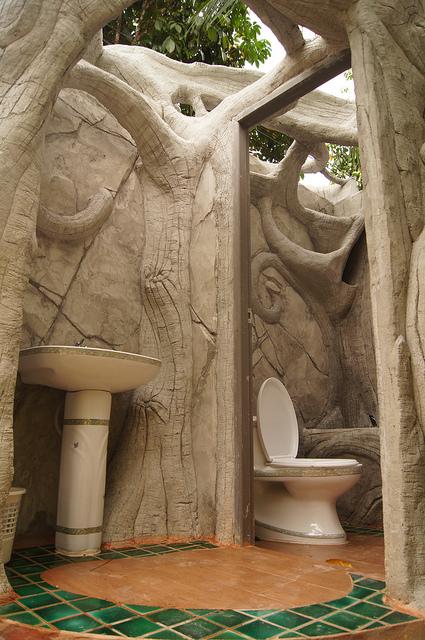Why does this bathroom lack privacy?
Give a very brief answer. Yes. How large is the statue?
Answer briefly. Large. What color are the diamond shapes on the floor?
Keep it brief. Green. What is this room used for?
Give a very brief answer. Bathroom. 